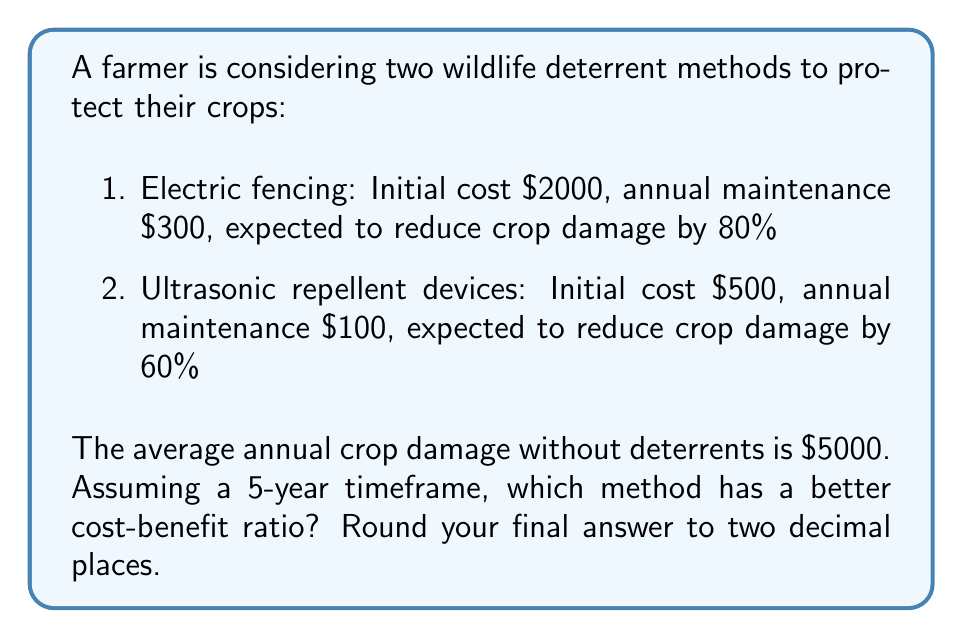Could you help me with this problem? Let's calculate the cost-benefit ratio for each method over 5 years:

1. Electric fencing:
   Total cost = Initial cost + (Annual maintenance × 5 years)
   $$ 2000 + (300 × 5) = 2000 + 1500 = $3500 $$
   
   Benefit = Crop damage reduction over 5 years
   $$ (5000 × 0.80) × 5 = 4000 × 5 = $20000 $$
   
   Cost-benefit ratio = Cost ÷ Benefit
   $$ \frac{3500}{20000} = 0.175 $$

2. Ultrasonic repellent devices:
   Total cost = Initial cost + (Annual maintenance × 5 years)
   $$ 500 + (100 × 5) = 500 + 500 = $1000 $$
   
   Benefit = Crop damage reduction over 5 years
   $$ (5000 × 0.60) × 5 = 3000 × 5 = $15000 $$
   
   Cost-benefit ratio = Cost ÷ Benefit
   $$ \frac{1000}{15000} = 0.0667 $$

A lower cost-benefit ratio indicates a better return on investment. The ultrasonic repellent devices have a lower ratio (0.0667) compared to the electric fencing (0.175), making it the better option in terms of cost-effectiveness.
Answer: 0.07 (Ultrasonic repellent devices) 